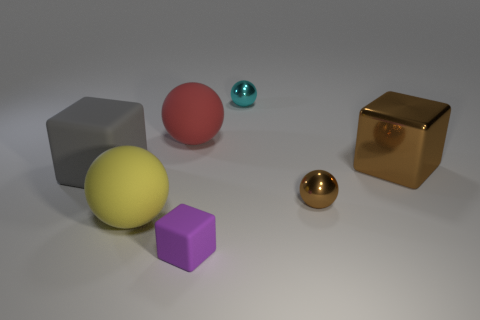Can you describe the texture or material properties visible in the objects? Certainly! The objects in the image appear to have different material properties. The grey cube looks matte with a slight roughness, which diffuses the light. The yellow sphere and the purple cube have a similar matte finish, but with smoother surfaces. The red sphere has a soft, velvety texture that absorbs the light. The brown sphere and cube have reflective, metallic surfaces, likely representing a material like polished bronze. The small teal sphere is also reflective, suggesting a smooth, perhaps metallic texture. 